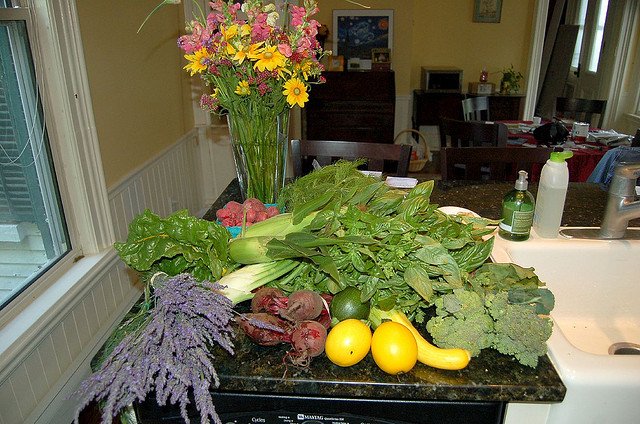<image>What is the name of the painting on the wall? I don't know the name of the painting on the wall. It may be 'picasso', 'starry night', 'abstract', 'flowers', or 'ode to lady'. What is the name of the painting on the wall? I don't know the name of the painting on the wall. It can be 'picasso', 'starry night', 'abstract', 'flowers', or 'ode to lady'. 